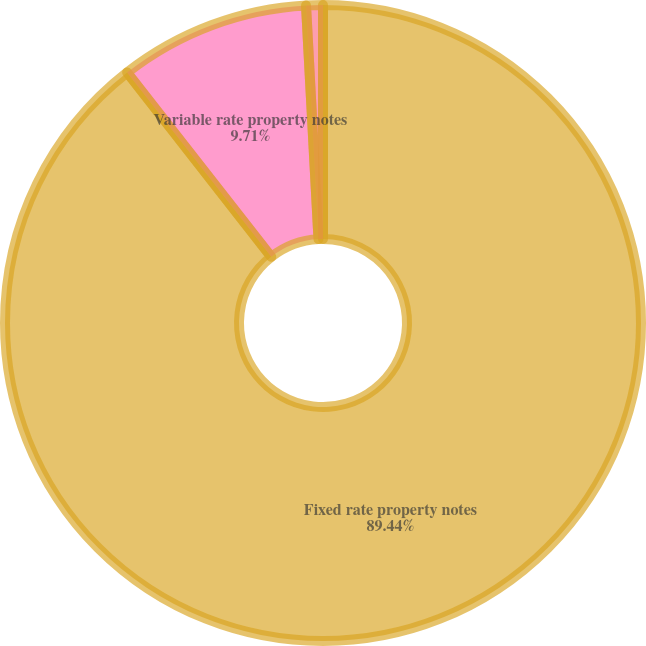<chart> <loc_0><loc_0><loc_500><loc_500><pie_chart><fcel>Fixed rate property notes<fcel>Variable rate property notes<fcel>Secured notes credit facility<nl><fcel>89.43%<fcel>9.71%<fcel>0.85%<nl></chart> 